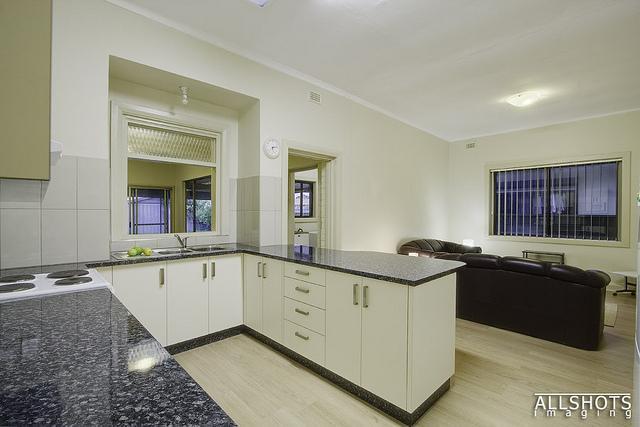How many drawers are open?
Give a very brief answer. 0. 